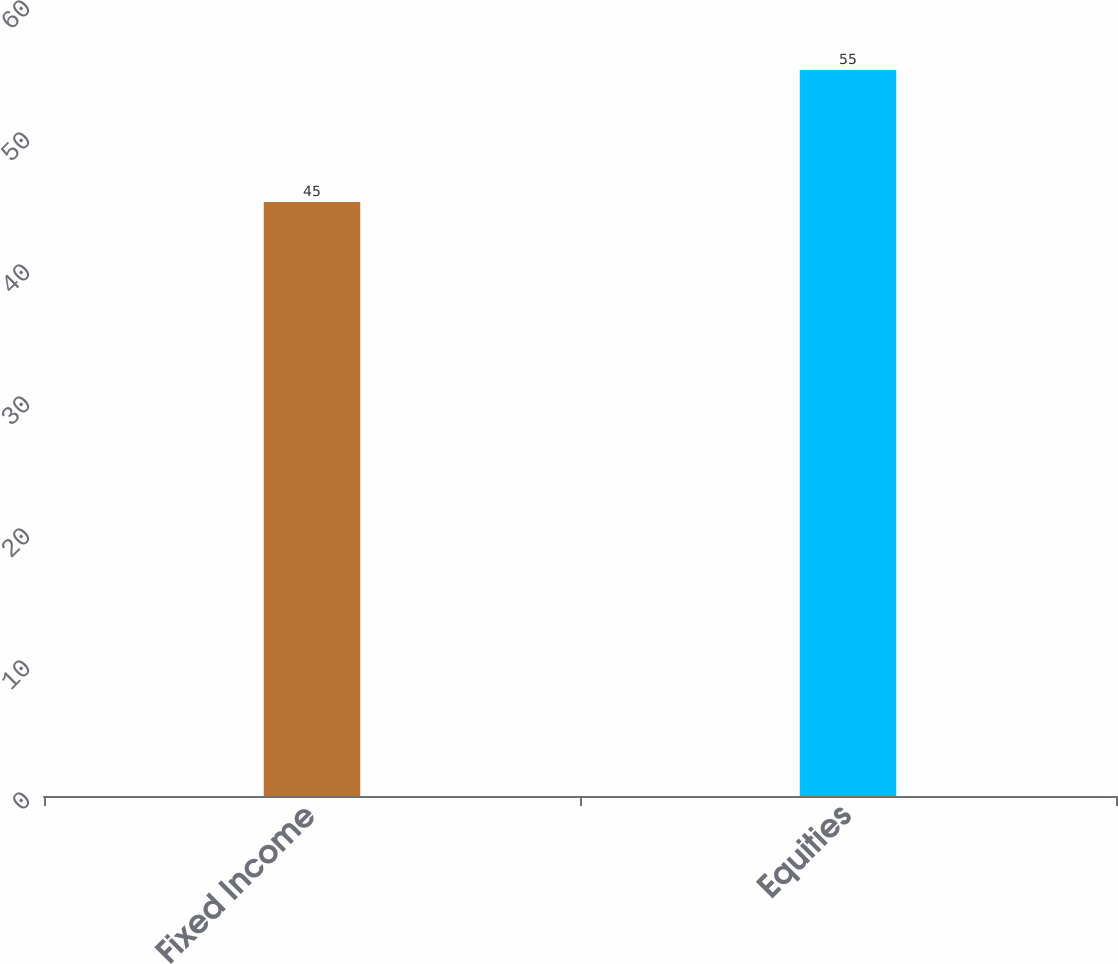Convert chart. <chart><loc_0><loc_0><loc_500><loc_500><bar_chart><fcel>Fixed Income<fcel>Equities<nl><fcel>45<fcel>55<nl></chart> 